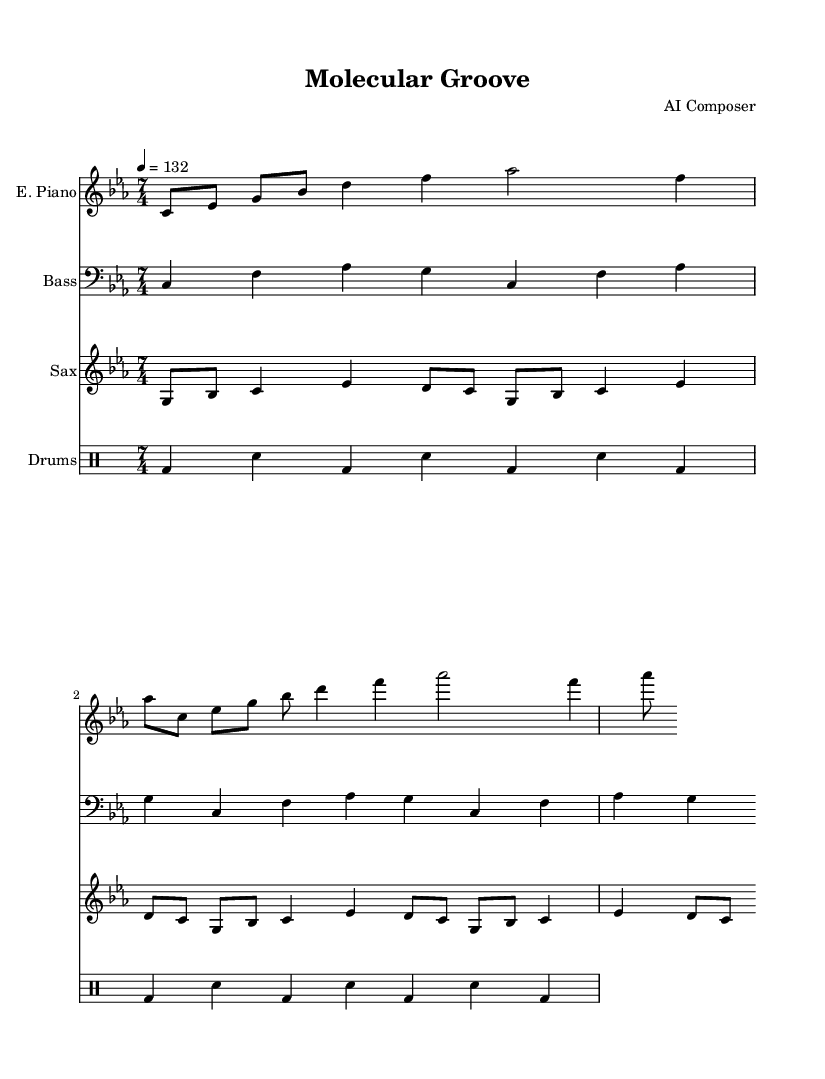What is the key signature of this music? The key signature is C minor, which typically includes the notes C, D, E♭, F, G, A♭, and B♭. The presence of E♭ and A♭ in the melody indicates the key is minor.
Answer: C minor What is the time signature of this music? The time signature is indicated at the beginning of the score as 7/4, meaning there are seven beats in each measure with a quarter note receiving one beat.
Answer: 7/4 What is the tempo of this piece? The tempo marking indicates that the music should be played at a speed of 132 beats per minute, facilitated by the marking "4 = 132."
Answer: 132 Which instrument plays the saxophone part? The saxophone part is labeled with "Sax" on the staff, indicating that it is performed by a saxophone player.
Answer: Saxophone How many measures are in the electric piano section? By counting the number of distinct groupings of notes divided by the bar lines in the electric piano part, there are 8 measures total.
Answer: 8 What rhythmic patterns do the drums use? The drum patterns consist of alternating bass drum and snare hits, represented by "bd" and "sn," creating a syncopated rhythm in 4/4 time.
Answer: Bass and snare What is the title of this music piece? The title is presented at the top of the score, written as "Molecular Groove," indicating a conceptual link to the themes of innovation in pharmaceutical research.
Answer: Molecular Groove 